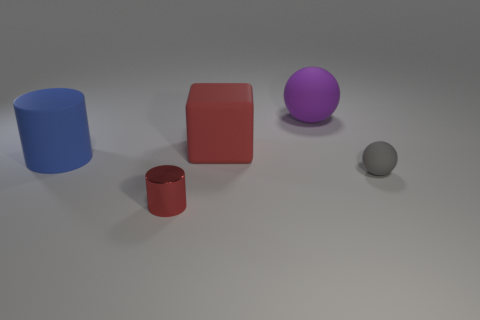What size is the other object that is the same shape as the metallic object?
Your answer should be very brief. Large. Are there more matte spheres that are on the left side of the tiny gray matte ball than tiny gray rubber things that are behind the big cylinder?
Make the answer very short. Yes. Are there any other rubber objects of the same shape as the small gray rubber thing?
Your response must be concise. Yes. There is a blue matte cylinder behind the tiny thing left of the small gray object; how big is it?
Provide a succinct answer. Large. There is a red thing that is in front of the sphere that is in front of the rubber ball that is to the left of the tiny gray matte ball; what shape is it?
Provide a succinct answer. Cylinder. What size is the gray sphere that is made of the same material as the big blue cylinder?
Provide a short and direct response. Small. Is the number of large objects greater than the number of red things?
Your answer should be compact. Yes. What is the material of the blue thing that is the same size as the block?
Offer a very short reply. Rubber. There is a object in front of the gray sphere; does it have the same size as the tiny gray matte ball?
Provide a short and direct response. Yes. How many cylinders are either big red things or blue matte things?
Provide a succinct answer. 1. 